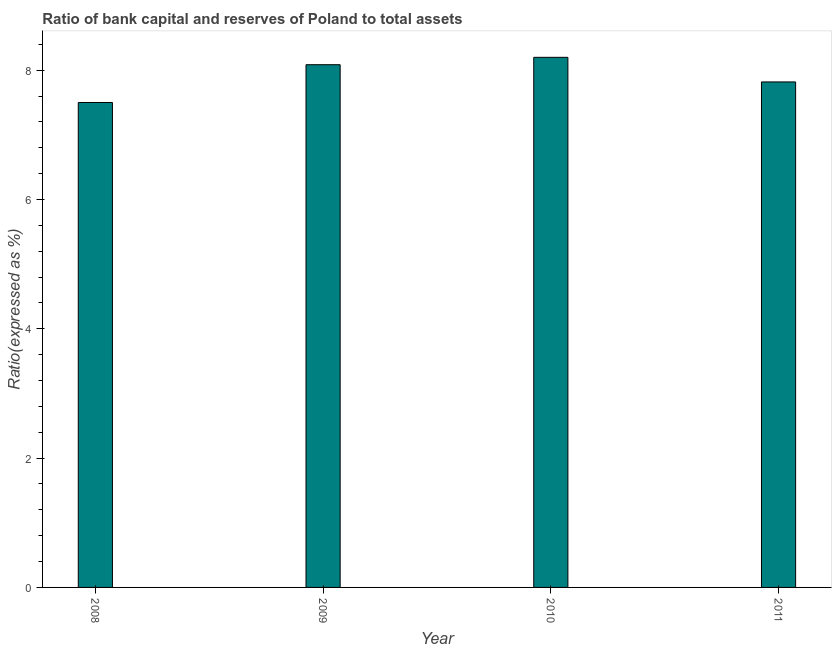What is the title of the graph?
Give a very brief answer. Ratio of bank capital and reserves of Poland to total assets. What is the label or title of the Y-axis?
Make the answer very short. Ratio(expressed as %). What is the bank capital to assets ratio in 2011?
Provide a short and direct response. 7.82. Across all years, what is the maximum bank capital to assets ratio?
Give a very brief answer. 8.2. In which year was the bank capital to assets ratio maximum?
Offer a very short reply. 2010. What is the sum of the bank capital to assets ratio?
Your response must be concise. 31.6. What is the difference between the bank capital to assets ratio in 2009 and 2011?
Offer a terse response. 0.27. What is the median bank capital to assets ratio?
Keep it short and to the point. 7.95. What is the ratio of the bank capital to assets ratio in 2010 to that in 2011?
Ensure brevity in your answer.  1.05. Is the difference between the bank capital to assets ratio in 2009 and 2010 greater than the difference between any two years?
Make the answer very short. No. What is the difference between the highest and the second highest bank capital to assets ratio?
Give a very brief answer. 0.11. What is the difference between the highest and the lowest bank capital to assets ratio?
Give a very brief answer. 0.7. In how many years, is the bank capital to assets ratio greater than the average bank capital to assets ratio taken over all years?
Your response must be concise. 2. How many bars are there?
Offer a terse response. 4. What is the Ratio(expressed as %) in 2008?
Offer a very short reply. 7.5. What is the Ratio(expressed as %) in 2009?
Offer a terse response. 8.08. What is the Ratio(expressed as %) of 2010?
Offer a terse response. 8.2. What is the Ratio(expressed as %) in 2011?
Your answer should be very brief. 7.82. What is the difference between the Ratio(expressed as %) in 2008 and 2009?
Ensure brevity in your answer.  -0.58. What is the difference between the Ratio(expressed as %) in 2008 and 2010?
Keep it short and to the point. -0.7. What is the difference between the Ratio(expressed as %) in 2008 and 2011?
Provide a succinct answer. -0.32. What is the difference between the Ratio(expressed as %) in 2009 and 2010?
Offer a very short reply. -0.11. What is the difference between the Ratio(expressed as %) in 2009 and 2011?
Your response must be concise. 0.27. What is the difference between the Ratio(expressed as %) in 2010 and 2011?
Make the answer very short. 0.38. What is the ratio of the Ratio(expressed as %) in 2008 to that in 2009?
Ensure brevity in your answer.  0.93. What is the ratio of the Ratio(expressed as %) in 2008 to that in 2010?
Your response must be concise. 0.92. What is the ratio of the Ratio(expressed as %) in 2009 to that in 2011?
Provide a succinct answer. 1.03. What is the ratio of the Ratio(expressed as %) in 2010 to that in 2011?
Give a very brief answer. 1.05. 